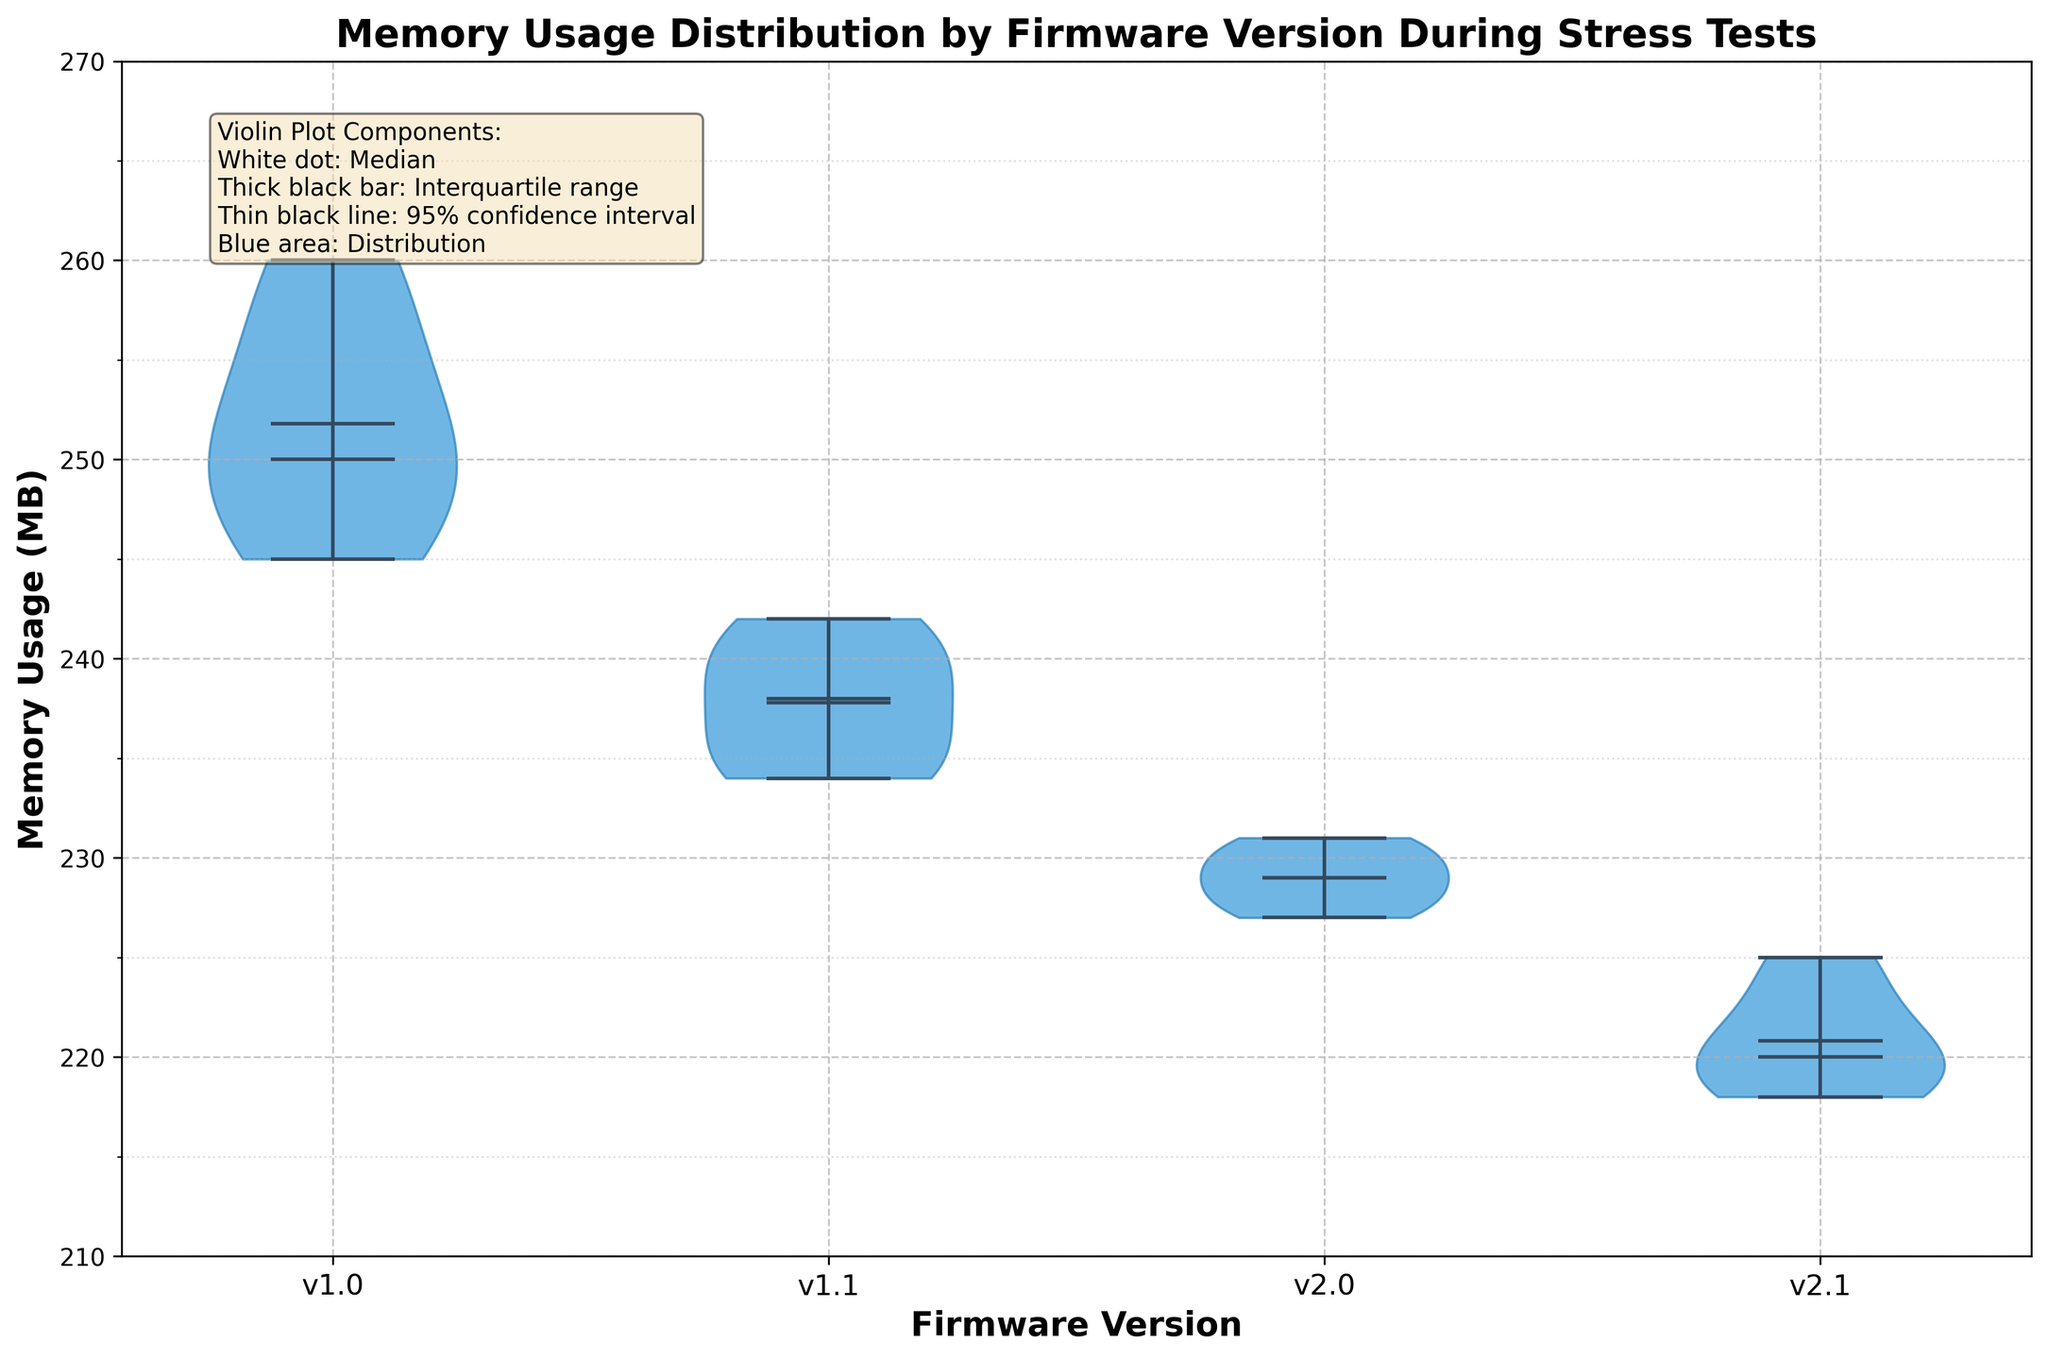What's the title of the figure? The title of the plot is usually written at the top. Here, the title is "Memory Usage Distribution by Firmware Version During Stress Tests."
Answer: Memory Usage Distribution by Firmware Version During Stress Tests What are the firmware versions compared in this figure? The x-axis labels represent the firmware versions compared in the figure. These are 'v1.0', 'v1.1', 'v2.0', and 'v2.1'.
Answer: 'v1.0', 'v1.1', 'v2.0', 'v2.1' What is the memory usage value range displayed on the y-axis? The y-axis shows the scale of memory usage values. Here, it ranges from 210 to 270 MB as per the y-axis limits set in the plot.
Answer: 210 to 270 MB Which firmware version has the lowest median memory usage? The median of each firmware version is the white dot in the respective violin plot. By comparing the medians, 'v2.1' shows the lowest median memory usage.
Answer: v2.1 What visual element represents the median in each violin plot? The legend text box explains the components of the violin plot. The white dot represents the median.
Answer: White dot Which firmware version shows the broadest memory usage distribution? The width of the blue area in the violin plot indicates the distribution. 'v1.0' has the widest distribution among the firmware versions.
Answer: v1.0 What is the interquartile range for firmware version v1.0? The thick black bar in each violin plot indicates the interquartile range (IQR). For 'v1.0', this range stretches from roughly 245 MB to 255 MB.
Answer: Approximately 245 to 255 MB How does the variability in memory usage of v1.1 compare to v2.0? The variability is shown by the width of the violin plots. 'v1.1' has a notably wider violin plot than 'v2.0', indicating higher variability.
Answer: v1.1 has higher variability How does the mean memory usage of v1.0 compare to v2.1? The mean is shown by a dot, often different in color (black dot) within the violin plot. By comparing their positions, 'v1.0' has a higher mean memory usage than 'v2.1'.
Answer: v1.0 has higher mean memory usage What is emphasized through the dashed and dotted lines in the grid? The grid lines with different styles (dashed for major, dotted for minor) help in better reading of the y-axis, emphasizing major and minor ticks.
Answer: Difference between major and minor y-axis ticks 